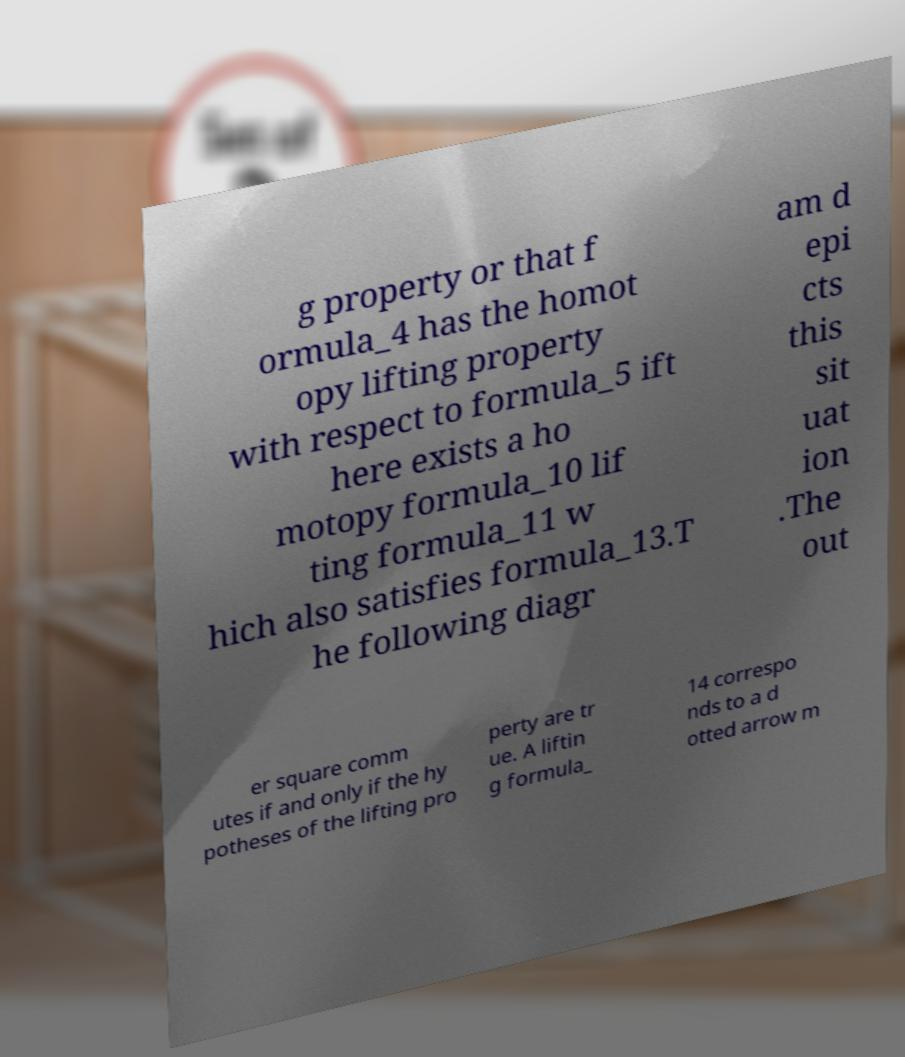Can you read and provide the text displayed in the image?This photo seems to have some interesting text. Can you extract and type it out for me? g property or that f ormula_4 has the homot opy lifting property with respect to formula_5 ift here exists a ho motopy formula_10 lif ting formula_11 w hich also satisfies formula_13.T he following diagr am d epi cts this sit uat ion .The out er square comm utes if and only if the hy potheses of the lifting pro perty are tr ue. A liftin g formula_ 14 correspo nds to a d otted arrow m 